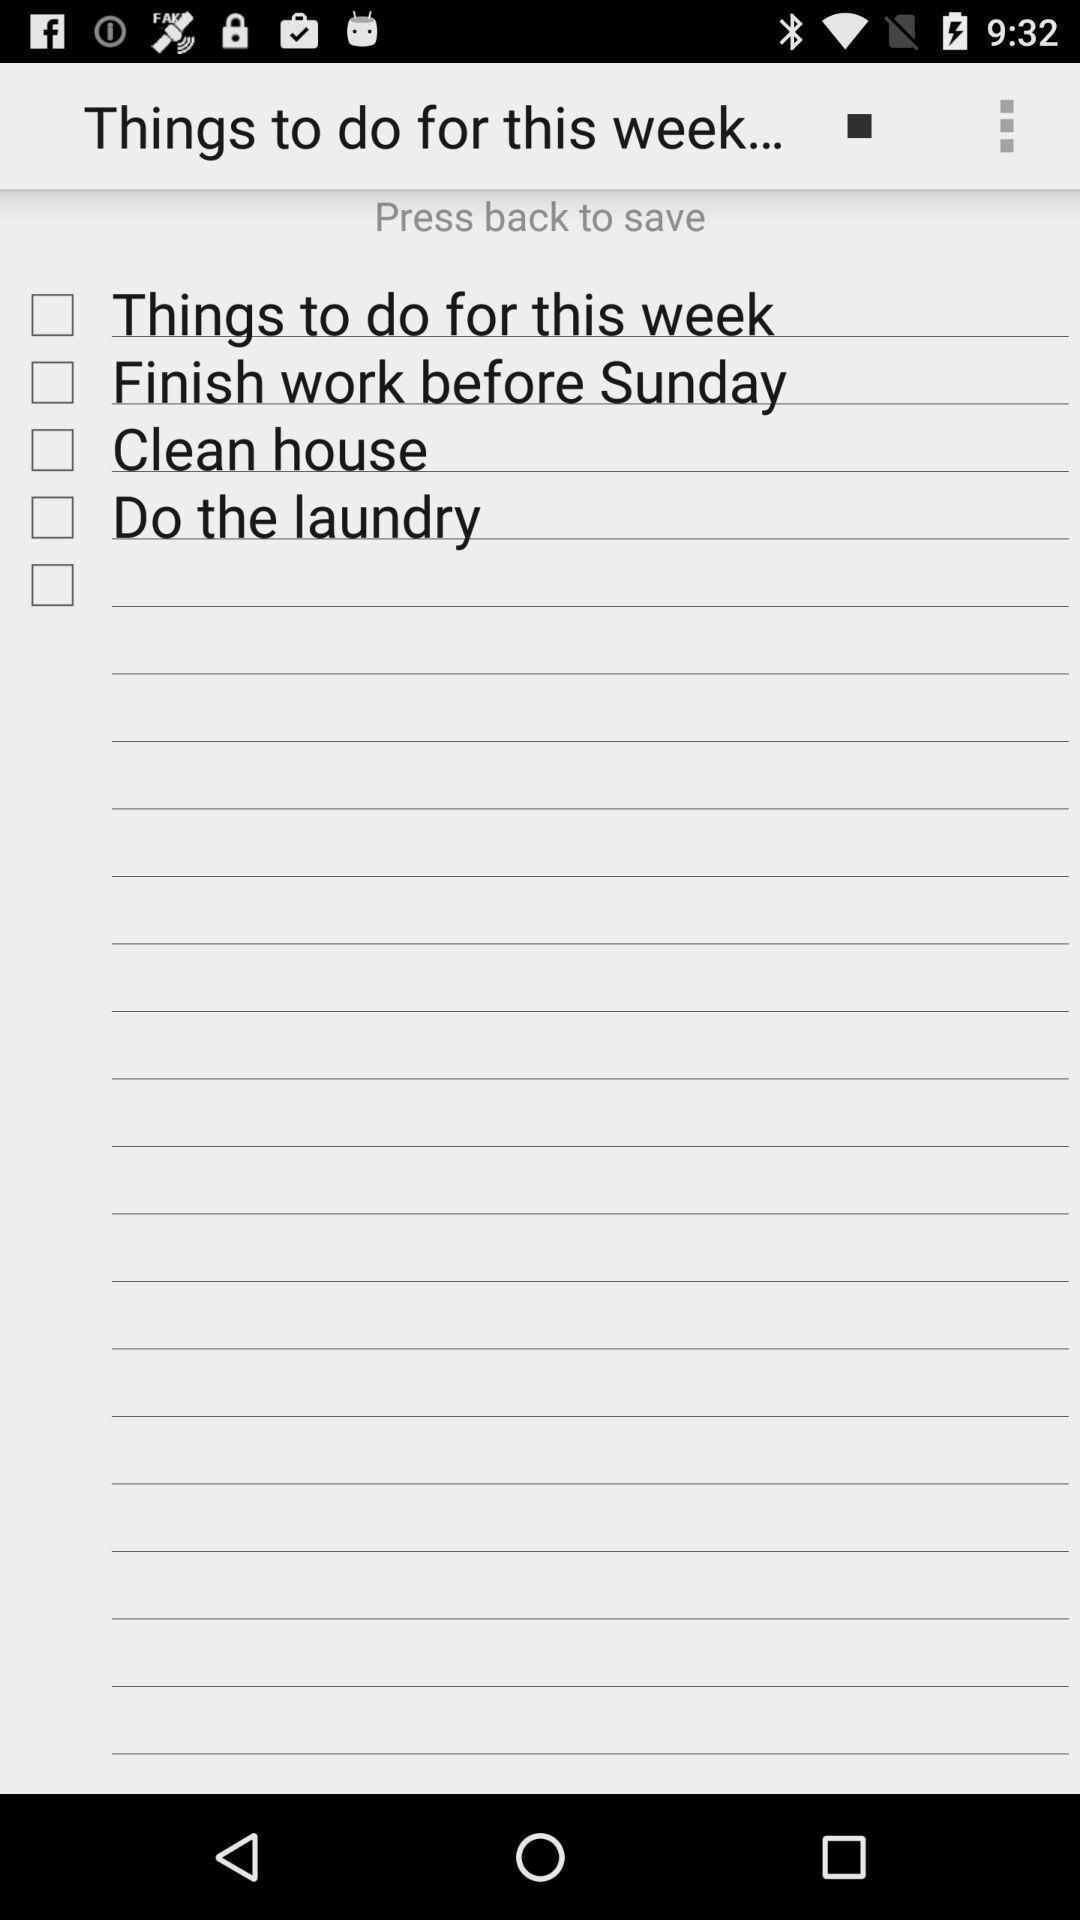Where do we need to press to save? You need to press back to save. 